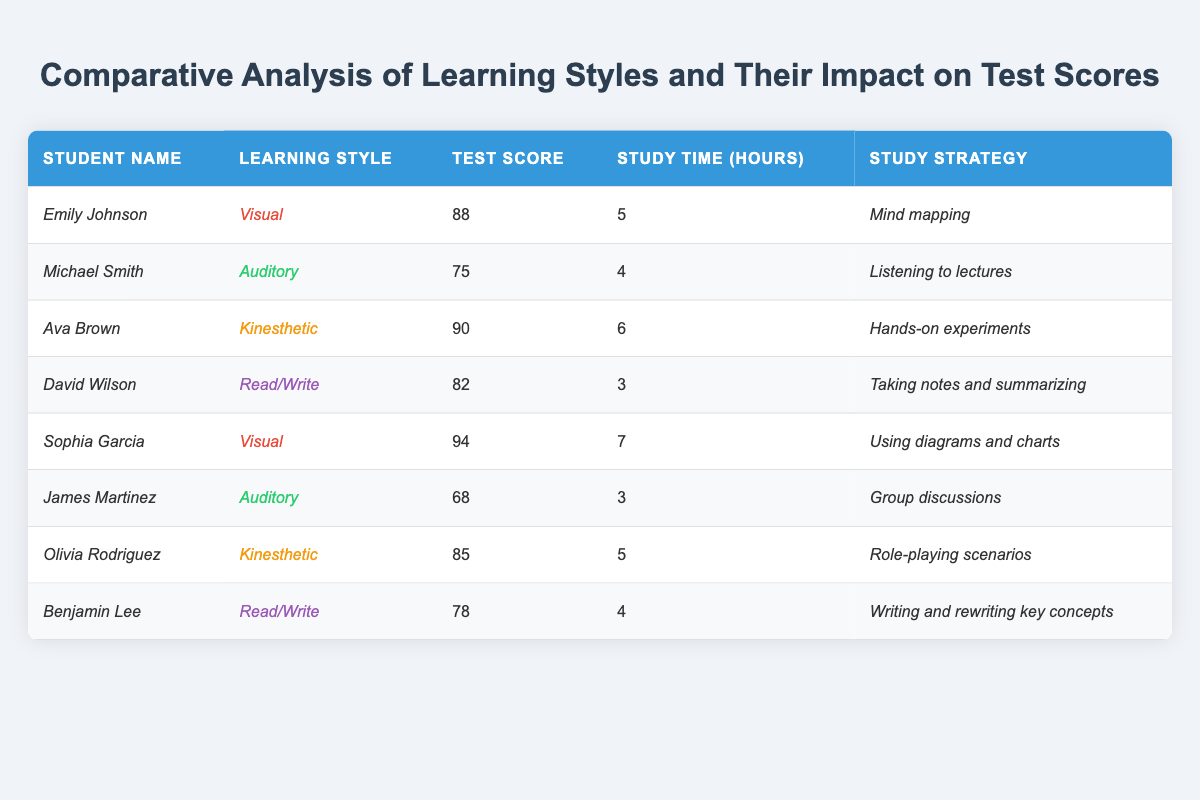What is the test score of Emily Johnson? Emily Johnson's test score is explicitly listed in the table under her row, which shows a score of 88.
Answer: 88 What study strategy did Sophia Garcia use? The study strategy for Sophia Garcia is noted in her row, which states that she used "Using diagrams and charts."
Answer: Using diagrams and charts How many hours did David Wilson study? David Wilson's study hours are indicated in the table next to his name, showing he studied for 3 hours.
Answer: 3 hours Which student scored the highest on the test? By comparing all the test scores in the table, Sophia Garcia has the highest score, which is 94.
Answer: Sophia Garcia What is the average test score of the students with a kinesthetic learning style? The scores for the kinesthetic learners, Ava Brown (90) and Olivia Rodriguez (85), need to be averaged. The sum is 90 + 85 = 175 and there are 2 students, so the average is 175/2 = 87.5.
Answer: 87.5 Did any auditory learner score above 70? In the table, there are two auditory learners: Michael Smith (score 75) and James Martinez (score 68). Since 75 is above 70 and 68 is not, the answer is yes.
Answer: Yes Which learning style has the highest average test score? The average scores for each learning style must be calculated: Visual (88 + 94)/2 = 91, Auditory (75 + 68)/2 = 71.5, Kinesthetic (90 + 85)/2 = 87.5, and Read/Write (82 + 78)/2 = 80. The highest average is for Visual.
Answer: Visual Was the study time for the highest scoring student greater than 5 hours? The highest score is 94 achieved by Sophia Garcia, who studied for 7 hours, which is greater than 5.
Answer: Yes What is the total study time of all students listed? The study times are 5 (Emily) + 4 (Michael) + 6 (Ava) + 3 (David) + 7 (Sophia) + 3 (James) + 5 (Olivia) + 4 (Benjamin) = 37 hours in total.
Answer: 37 hours How does the test score of students who studied more than 5 hours compare to those who studied less? Students who studied more than 5 hours are (Ava 90, Sophia 94) and those who studied less than or equal to 5 hours include (Emily 88, Michael 75, David 82, James 68, Olivia 85, Benjamin 78). The average for >5 hours is (90 + 94)/2 = 92, while for ≤5 hours it is (88 + 75 + 82 + 68 + 85 + 78)/6 = 79. The students who studied more scored higher.
Answer: Students who studied more scored higher 